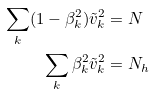<formula> <loc_0><loc_0><loc_500><loc_500>\sum _ { k } ( 1 - \beta _ { k } ^ { 2 } ) \tilde { v } _ { k } ^ { 2 } & = N \\ \sum _ { k } \beta _ { k } ^ { 2 } \tilde { v } _ { k } ^ { 2 } & = N _ { h }</formula> 